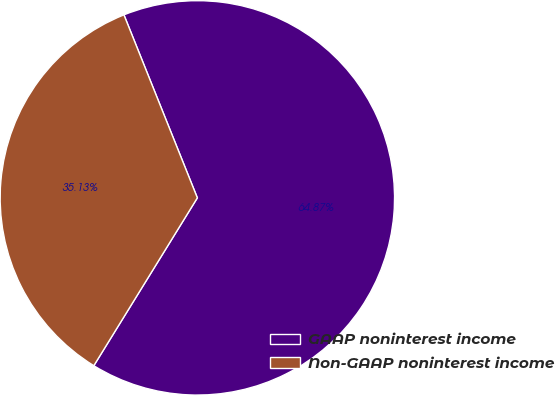Convert chart. <chart><loc_0><loc_0><loc_500><loc_500><pie_chart><fcel>GAAP noninterest income<fcel>Non-GAAP noninterest income<nl><fcel>64.87%<fcel>35.13%<nl></chart> 